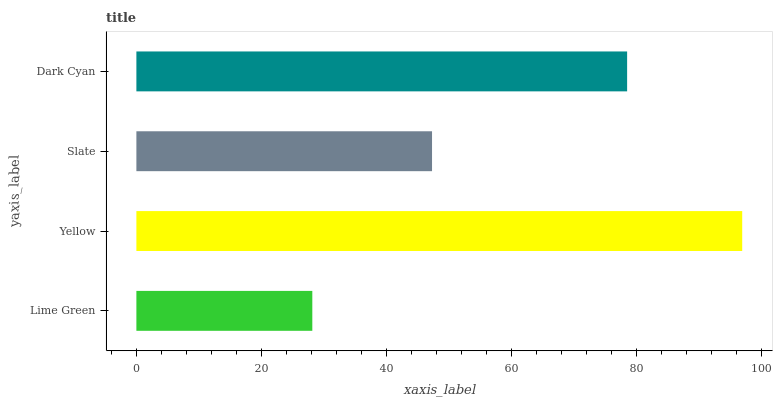Is Lime Green the minimum?
Answer yes or no. Yes. Is Yellow the maximum?
Answer yes or no. Yes. Is Slate the minimum?
Answer yes or no. No. Is Slate the maximum?
Answer yes or no. No. Is Yellow greater than Slate?
Answer yes or no. Yes. Is Slate less than Yellow?
Answer yes or no. Yes. Is Slate greater than Yellow?
Answer yes or no. No. Is Yellow less than Slate?
Answer yes or no. No. Is Dark Cyan the high median?
Answer yes or no. Yes. Is Slate the low median?
Answer yes or no. Yes. Is Slate the high median?
Answer yes or no. No. Is Yellow the low median?
Answer yes or no. No. 